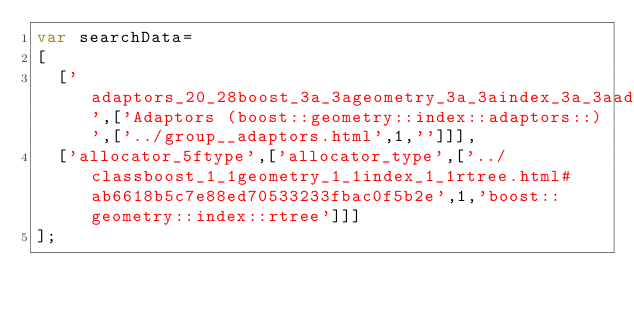<code> <loc_0><loc_0><loc_500><loc_500><_JavaScript_>var searchData=
[
  ['adaptors_20_28boost_3a_3ageometry_3a_3aindex_3a_3aadaptors_3a_3a_29',['Adaptors (boost::geometry::index::adaptors::)',['../group__adaptors.html',1,'']]],
  ['allocator_5ftype',['allocator_type',['../classboost_1_1geometry_1_1index_1_1rtree.html#ab6618b5c7e88ed70533233fbac0f5b2e',1,'boost::geometry::index::rtree']]]
];
</code> 